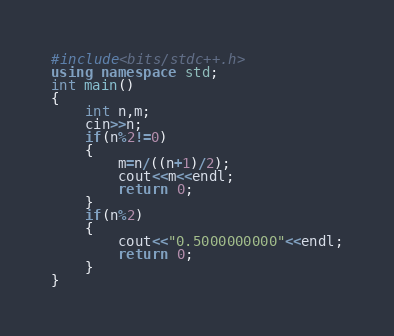Convert code to text. <code><loc_0><loc_0><loc_500><loc_500><_C++_>#include<bits/stdc++.h>
using namespace std;
int main()
{
	int n,m;
	cin>>n;
	if(n%2!=0)
	{
		m=n/((n+1)/2);
		cout<<m<<endl;
		return 0;
	}
	if(n%2)
	{
		cout<<"0.5000000000"<<endl;
		return 0;
	}
}</code> 